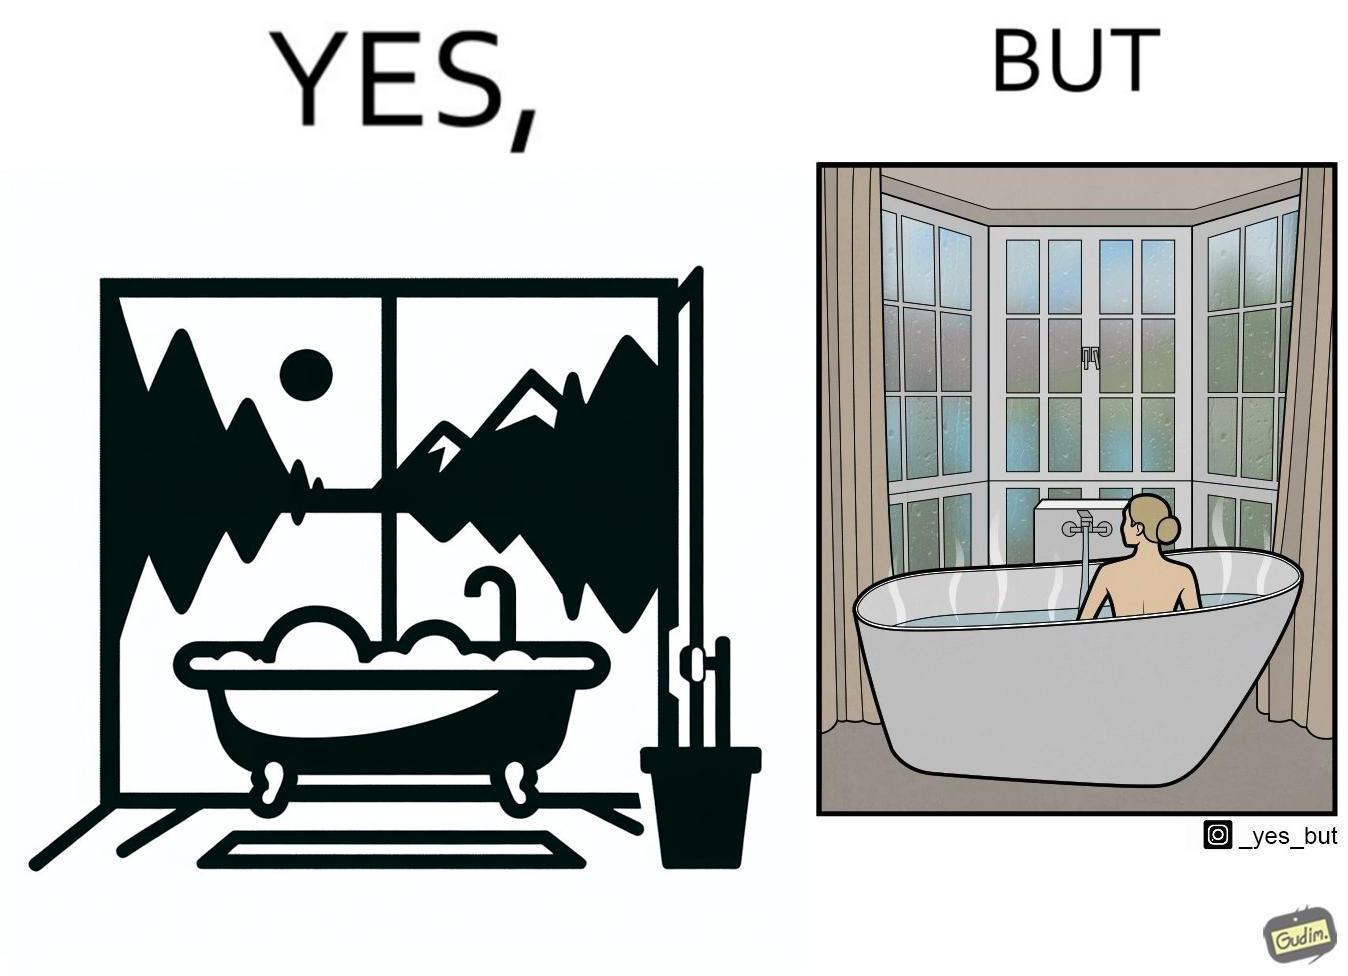What is shown in the left half versus the right half of this image? In the left part of the image: a bathtub by the side of a window which has a very scenic view of lake and mountains. In the right part of the image: a woman bathing in a bathtub, while the window glasses are foggy from the steam of the hot water. 